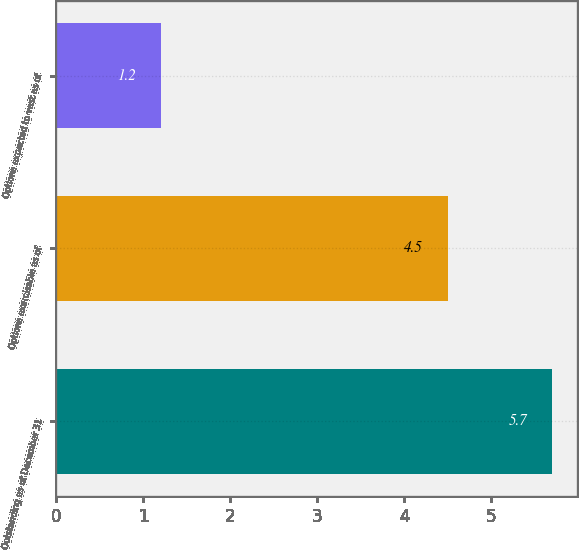<chart> <loc_0><loc_0><loc_500><loc_500><bar_chart><fcel>Outstanding as of December 31<fcel>Options exercisable as of<fcel>Options expected to vest as of<nl><fcel>5.7<fcel>4.5<fcel>1.2<nl></chart> 